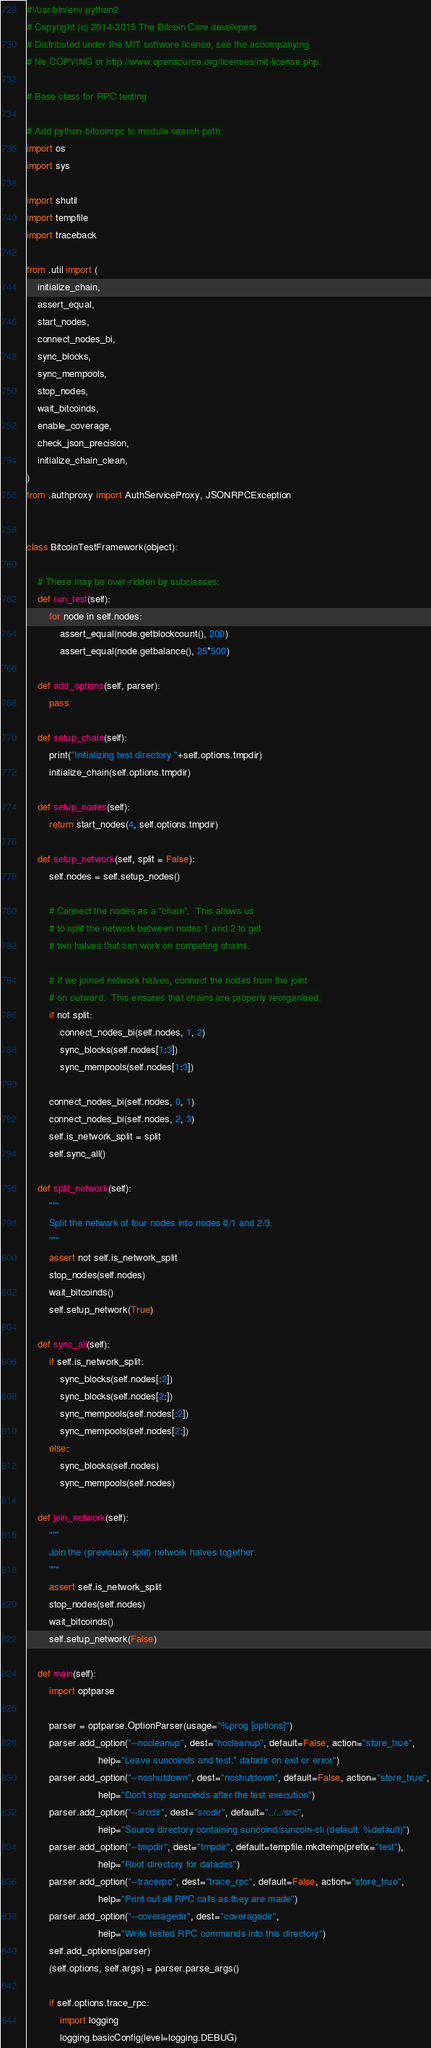Convert code to text. <code><loc_0><loc_0><loc_500><loc_500><_Python_>#!/usr/bin/env python2
# Copyright (c) 2014-2015 The Bitcoin Core developers
# Distributed under the MIT software license, see the accompanying
# file COPYING or http://www.opensource.org/licenses/mit-license.php.

# Base class for RPC testing

# Add python-bitcoinrpc to module search path:
import os
import sys

import shutil
import tempfile
import traceback

from .util import (
    initialize_chain,
    assert_equal,
    start_nodes,
    connect_nodes_bi,
    sync_blocks,
    sync_mempools,
    stop_nodes,
    wait_bitcoinds,
    enable_coverage,
    check_json_precision,
    initialize_chain_clean,
)
from .authproxy import AuthServiceProxy, JSONRPCException


class BitcoinTestFramework(object):

    # These may be over-ridden by subclasses:
    def run_test(self):
        for node in self.nodes:
            assert_equal(node.getblockcount(), 200)
            assert_equal(node.getbalance(), 25*500)

    def add_options(self, parser):
        pass

    def setup_chain(self):
        print("Initializing test directory "+self.options.tmpdir)
        initialize_chain(self.options.tmpdir)

    def setup_nodes(self):
        return start_nodes(4, self.options.tmpdir)

    def setup_network(self, split = False):
        self.nodes = self.setup_nodes()

        # Connect the nodes as a "chain".  This allows us
        # to split the network between nodes 1 and 2 to get
        # two halves that can work on competing chains.

        # If we joined network halves, connect the nodes from the joint
        # on outward.  This ensures that chains are properly reorganised.
        if not split:
            connect_nodes_bi(self.nodes, 1, 2)
            sync_blocks(self.nodes[1:3])
            sync_mempools(self.nodes[1:3])

        connect_nodes_bi(self.nodes, 0, 1)
        connect_nodes_bi(self.nodes, 2, 3)
        self.is_network_split = split
        self.sync_all()

    def split_network(self):
        """
        Split the network of four nodes into nodes 0/1 and 2/3.
        """
        assert not self.is_network_split
        stop_nodes(self.nodes)
        wait_bitcoinds()
        self.setup_network(True)

    def sync_all(self):
        if self.is_network_split:
            sync_blocks(self.nodes[:2])
            sync_blocks(self.nodes[2:])
            sync_mempools(self.nodes[:2])
            sync_mempools(self.nodes[2:])
        else:
            sync_blocks(self.nodes)
            sync_mempools(self.nodes)

    def join_network(self):
        """
        Join the (previously split) network halves together.
        """
        assert self.is_network_split
        stop_nodes(self.nodes)
        wait_bitcoinds()
        self.setup_network(False)

    def main(self):
        import optparse

        parser = optparse.OptionParser(usage="%prog [options]")
        parser.add_option("--nocleanup", dest="nocleanup", default=False, action="store_true",
                          help="Leave suncoinds and test.* datadir on exit or error")
        parser.add_option("--noshutdown", dest="noshutdown", default=False, action="store_true",
                          help="Don't stop suncoinds after the test execution")
        parser.add_option("--srcdir", dest="srcdir", default="../../src",
                          help="Source directory containing suncoind/suncoin-cli (default: %default)")
        parser.add_option("--tmpdir", dest="tmpdir", default=tempfile.mkdtemp(prefix="test"),
                          help="Root directory for datadirs")
        parser.add_option("--tracerpc", dest="trace_rpc", default=False, action="store_true",
                          help="Print out all RPC calls as they are made")
        parser.add_option("--coveragedir", dest="coveragedir",
                          help="Write tested RPC commands into this directory")
        self.add_options(parser)
        (self.options, self.args) = parser.parse_args()

        if self.options.trace_rpc:
            import logging
            logging.basicConfig(level=logging.DEBUG)
</code> 